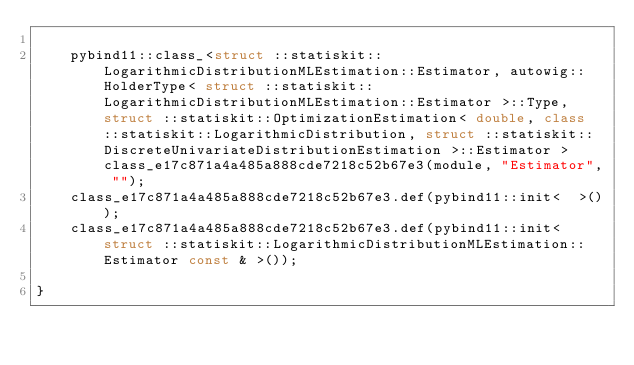Convert code to text. <code><loc_0><loc_0><loc_500><loc_500><_C++_>
    pybind11::class_<struct ::statiskit::LogarithmicDistributionMLEstimation::Estimator, autowig::HolderType< struct ::statiskit::LogarithmicDistributionMLEstimation::Estimator >::Type, struct ::statiskit::OptimizationEstimation< double, class ::statiskit::LogarithmicDistribution, struct ::statiskit::DiscreteUnivariateDistributionEstimation >::Estimator > class_e17c871a4a485a888cde7218c52b67e3(module, "Estimator", "");
    class_e17c871a4a485a888cde7218c52b67e3.def(pybind11::init<  >());
    class_e17c871a4a485a888cde7218c52b67e3.def(pybind11::init< struct ::statiskit::LogarithmicDistributionMLEstimation::Estimator const & >());

}</code> 